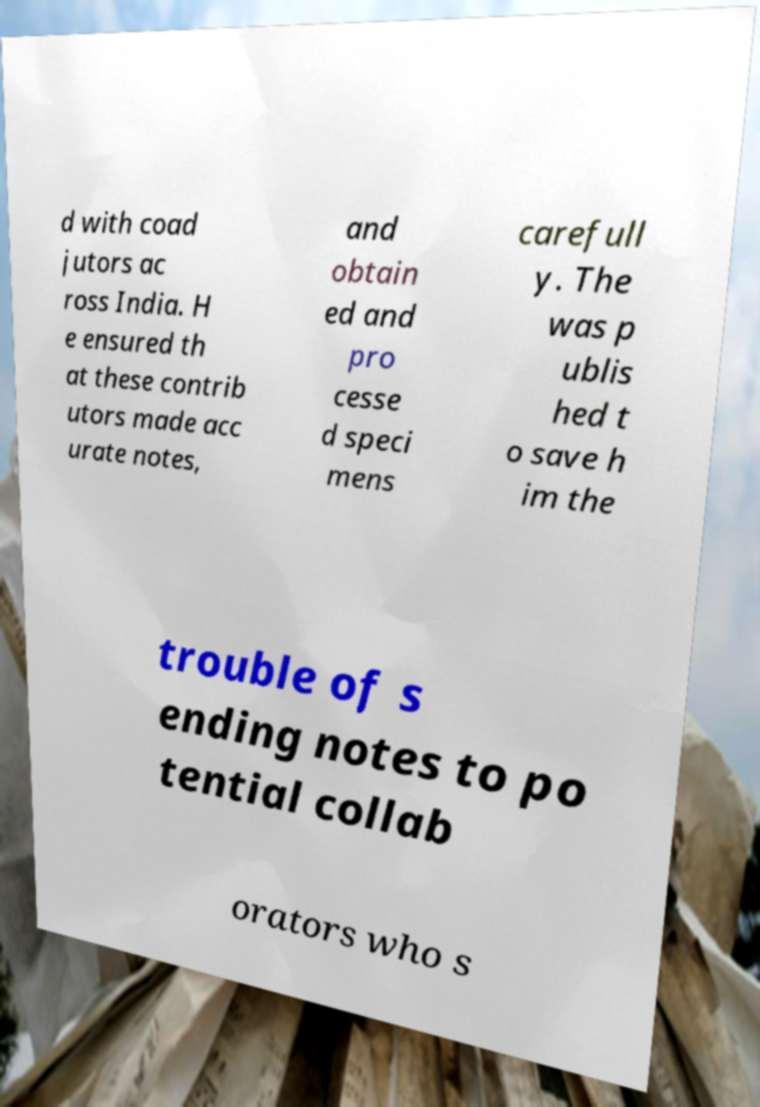For documentation purposes, I need the text within this image transcribed. Could you provide that? d with coad jutors ac ross India. H e ensured th at these contrib utors made acc urate notes, and obtain ed and pro cesse d speci mens carefull y. The was p ublis hed t o save h im the trouble of s ending notes to po tential collab orators who s 